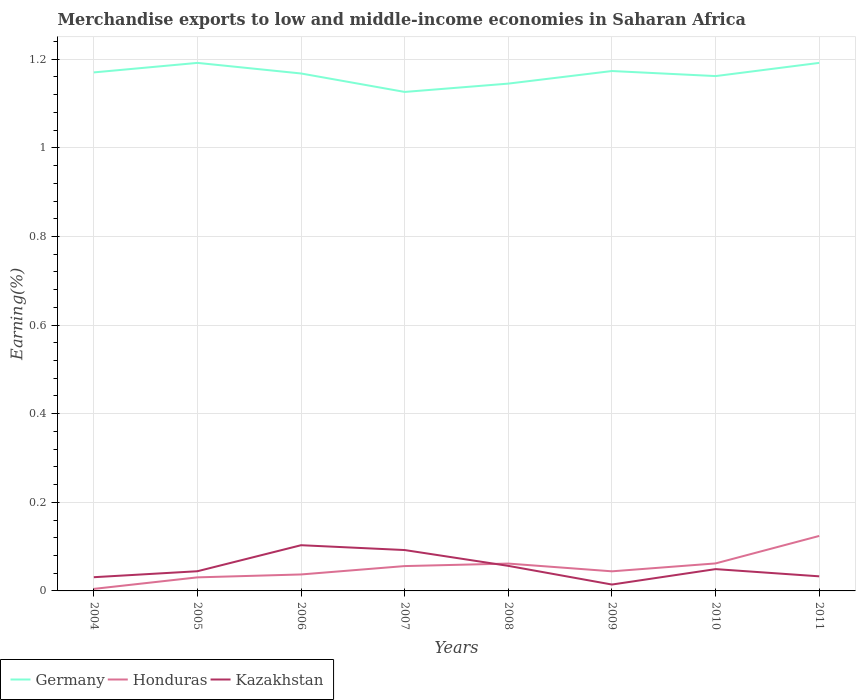How many different coloured lines are there?
Your answer should be compact. 3. Does the line corresponding to Honduras intersect with the line corresponding to Germany?
Offer a terse response. No. Is the number of lines equal to the number of legend labels?
Give a very brief answer. Yes. Across all years, what is the maximum percentage of amount earned from merchandise exports in Kazakhstan?
Your response must be concise. 0.01. What is the total percentage of amount earned from merchandise exports in Honduras in the graph?
Offer a very short reply. -0.02. What is the difference between the highest and the second highest percentage of amount earned from merchandise exports in Germany?
Keep it short and to the point. 0.07. What is the difference between the highest and the lowest percentage of amount earned from merchandise exports in Honduras?
Provide a short and direct response. 4. How many lines are there?
Make the answer very short. 3. What is the difference between two consecutive major ticks on the Y-axis?
Offer a very short reply. 0.2. Are the values on the major ticks of Y-axis written in scientific E-notation?
Your answer should be very brief. No. Does the graph contain any zero values?
Provide a succinct answer. No. Where does the legend appear in the graph?
Offer a terse response. Bottom left. How are the legend labels stacked?
Offer a terse response. Horizontal. What is the title of the graph?
Your response must be concise. Merchandise exports to low and middle-income economies in Saharan Africa. Does "Rwanda" appear as one of the legend labels in the graph?
Offer a very short reply. No. What is the label or title of the X-axis?
Keep it short and to the point. Years. What is the label or title of the Y-axis?
Make the answer very short. Earning(%). What is the Earning(%) of Germany in 2004?
Give a very brief answer. 1.17. What is the Earning(%) of Honduras in 2004?
Offer a terse response. 0. What is the Earning(%) of Kazakhstan in 2004?
Give a very brief answer. 0.03. What is the Earning(%) of Germany in 2005?
Give a very brief answer. 1.19. What is the Earning(%) in Honduras in 2005?
Keep it short and to the point. 0.03. What is the Earning(%) in Kazakhstan in 2005?
Provide a succinct answer. 0.04. What is the Earning(%) in Germany in 2006?
Give a very brief answer. 1.17. What is the Earning(%) in Honduras in 2006?
Your response must be concise. 0.04. What is the Earning(%) of Kazakhstan in 2006?
Offer a very short reply. 0.1. What is the Earning(%) of Germany in 2007?
Provide a short and direct response. 1.13. What is the Earning(%) in Honduras in 2007?
Offer a very short reply. 0.06. What is the Earning(%) in Kazakhstan in 2007?
Ensure brevity in your answer.  0.09. What is the Earning(%) of Germany in 2008?
Keep it short and to the point. 1.14. What is the Earning(%) in Honduras in 2008?
Provide a short and direct response. 0.06. What is the Earning(%) in Kazakhstan in 2008?
Offer a very short reply. 0.06. What is the Earning(%) in Germany in 2009?
Give a very brief answer. 1.17. What is the Earning(%) of Honduras in 2009?
Make the answer very short. 0.04. What is the Earning(%) of Kazakhstan in 2009?
Offer a terse response. 0.01. What is the Earning(%) of Germany in 2010?
Your answer should be compact. 1.16. What is the Earning(%) of Honduras in 2010?
Make the answer very short. 0.06. What is the Earning(%) in Kazakhstan in 2010?
Provide a short and direct response. 0.05. What is the Earning(%) of Germany in 2011?
Keep it short and to the point. 1.19. What is the Earning(%) in Honduras in 2011?
Give a very brief answer. 0.12. What is the Earning(%) of Kazakhstan in 2011?
Provide a short and direct response. 0.03. Across all years, what is the maximum Earning(%) in Germany?
Ensure brevity in your answer.  1.19. Across all years, what is the maximum Earning(%) in Honduras?
Keep it short and to the point. 0.12. Across all years, what is the maximum Earning(%) of Kazakhstan?
Offer a very short reply. 0.1. Across all years, what is the minimum Earning(%) of Germany?
Offer a very short reply. 1.13. Across all years, what is the minimum Earning(%) of Honduras?
Offer a terse response. 0. Across all years, what is the minimum Earning(%) in Kazakhstan?
Your answer should be very brief. 0.01. What is the total Earning(%) in Germany in the graph?
Keep it short and to the point. 9.33. What is the total Earning(%) of Honduras in the graph?
Keep it short and to the point. 0.42. What is the total Earning(%) of Kazakhstan in the graph?
Your response must be concise. 0.42. What is the difference between the Earning(%) in Germany in 2004 and that in 2005?
Ensure brevity in your answer.  -0.02. What is the difference between the Earning(%) of Honduras in 2004 and that in 2005?
Your response must be concise. -0.03. What is the difference between the Earning(%) in Kazakhstan in 2004 and that in 2005?
Offer a terse response. -0.01. What is the difference between the Earning(%) of Germany in 2004 and that in 2006?
Make the answer very short. 0. What is the difference between the Earning(%) of Honduras in 2004 and that in 2006?
Give a very brief answer. -0.03. What is the difference between the Earning(%) of Kazakhstan in 2004 and that in 2006?
Your answer should be compact. -0.07. What is the difference between the Earning(%) in Germany in 2004 and that in 2007?
Give a very brief answer. 0.04. What is the difference between the Earning(%) in Honduras in 2004 and that in 2007?
Your response must be concise. -0.05. What is the difference between the Earning(%) in Kazakhstan in 2004 and that in 2007?
Your answer should be very brief. -0.06. What is the difference between the Earning(%) in Germany in 2004 and that in 2008?
Offer a very short reply. 0.03. What is the difference between the Earning(%) in Honduras in 2004 and that in 2008?
Provide a short and direct response. -0.06. What is the difference between the Earning(%) in Kazakhstan in 2004 and that in 2008?
Offer a very short reply. -0.03. What is the difference between the Earning(%) of Germany in 2004 and that in 2009?
Your answer should be very brief. -0. What is the difference between the Earning(%) of Honduras in 2004 and that in 2009?
Your answer should be very brief. -0.04. What is the difference between the Earning(%) in Kazakhstan in 2004 and that in 2009?
Keep it short and to the point. 0.02. What is the difference between the Earning(%) in Germany in 2004 and that in 2010?
Your answer should be very brief. 0.01. What is the difference between the Earning(%) in Honduras in 2004 and that in 2010?
Keep it short and to the point. -0.06. What is the difference between the Earning(%) in Kazakhstan in 2004 and that in 2010?
Offer a very short reply. -0.02. What is the difference between the Earning(%) of Germany in 2004 and that in 2011?
Provide a succinct answer. -0.02. What is the difference between the Earning(%) in Honduras in 2004 and that in 2011?
Provide a short and direct response. -0.12. What is the difference between the Earning(%) of Kazakhstan in 2004 and that in 2011?
Your answer should be very brief. -0. What is the difference between the Earning(%) in Germany in 2005 and that in 2006?
Offer a very short reply. 0.02. What is the difference between the Earning(%) in Honduras in 2005 and that in 2006?
Your response must be concise. -0.01. What is the difference between the Earning(%) of Kazakhstan in 2005 and that in 2006?
Your response must be concise. -0.06. What is the difference between the Earning(%) in Germany in 2005 and that in 2007?
Offer a very short reply. 0.07. What is the difference between the Earning(%) in Honduras in 2005 and that in 2007?
Provide a succinct answer. -0.03. What is the difference between the Earning(%) in Kazakhstan in 2005 and that in 2007?
Provide a succinct answer. -0.05. What is the difference between the Earning(%) in Germany in 2005 and that in 2008?
Your answer should be compact. 0.05. What is the difference between the Earning(%) in Honduras in 2005 and that in 2008?
Give a very brief answer. -0.03. What is the difference between the Earning(%) in Kazakhstan in 2005 and that in 2008?
Offer a very short reply. -0.01. What is the difference between the Earning(%) in Germany in 2005 and that in 2009?
Your answer should be very brief. 0.02. What is the difference between the Earning(%) in Honduras in 2005 and that in 2009?
Offer a terse response. -0.01. What is the difference between the Earning(%) in Germany in 2005 and that in 2010?
Your answer should be very brief. 0.03. What is the difference between the Earning(%) in Honduras in 2005 and that in 2010?
Make the answer very short. -0.03. What is the difference between the Earning(%) in Kazakhstan in 2005 and that in 2010?
Offer a very short reply. -0. What is the difference between the Earning(%) in Germany in 2005 and that in 2011?
Provide a succinct answer. -0. What is the difference between the Earning(%) in Honduras in 2005 and that in 2011?
Offer a very short reply. -0.09. What is the difference between the Earning(%) of Kazakhstan in 2005 and that in 2011?
Your response must be concise. 0.01. What is the difference between the Earning(%) of Germany in 2006 and that in 2007?
Your answer should be very brief. 0.04. What is the difference between the Earning(%) of Honduras in 2006 and that in 2007?
Offer a very short reply. -0.02. What is the difference between the Earning(%) in Kazakhstan in 2006 and that in 2007?
Offer a terse response. 0.01. What is the difference between the Earning(%) in Germany in 2006 and that in 2008?
Provide a short and direct response. 0.02. What is the difference between the Earning(%) in Honduras in 2006 and that in 2008?
Make the answer very short. -0.02. What is the difference between the Earning(%) of Kazakhstan in 2006 and that in 2008?
Ensure brevity in your answer.  0.05. What is the difference between the Earning(%) of Germany in 2006 and that in 2009?
Offer a terse response. -0.01. What is the difference between the Earning(%) of Honduras in 2006 and that in 2009?
Provide a short and direct response. -0.01. What is the difference between the Earning(%) of Kazakhstan in 2006 and that in 2009?
Offer a terse response. 0.09. What is the difference between the Earning(%) of Germany in 2006 and that in 2010?
Offer a terse response. 0.01. What is the difference between the Earning(%) in Honduras in 2006 and that in 2010?
Provide a short and direct response. -0.02. What is the difference between the Earning(%) in Kazakhstan in 2006 and that in 2010?
Offer a terse response. 0.05. What is the difference between the Earning(%) of Germany in 2006 and that in 2011?
Your answer should be compact. -0.02. What is the difference between the Earning(%) of Honduras in 2006 and that in 2011?
Provide a succinct answer. -0.09. What is the difference between the Earning(%) of Kazakhstan in 2006 and that in 2011?
Make the answer very short. 0.07. What is the difference between the Earning(%) in Germany in 2007 and that in 2008?
Offer a terse response. -0.02. What is the difference between the Earning(%) in Honduras in 2007 and that in 2008?
Make the answer very short. -0.01. What is the difference between the Earning(%) in Kazakhstan in 2007 and that in 2008?
Provide a short and direct response. 0.04. What is the difference between the Earning(%) of Germany in 2007 and that in 2009?
Your response must be concise. -0.05. What is the difference between the Earning(%) of Honduras in 2007 and that in 2009?
Provide a succinct answer. 0.01. What is the difference between the Earning(%) of Kazakhstan in 2007 and that in 2009?
Your answer should be compact. 0.08. What is the difference between the Earning(%) in Germany in 2007 and that in 2010?
Provide a succinct answer. -0.04. What is the difference between the Earning(%) in Honduras in 2007 and that in 2010?
Your response must be concise. -0.01. What is the difference between the Earning(%) in Kazakhstan in 2007 and that in 2010?
Make the answer very short. 0.04. What is the difference between the Earning(%) in Germany in 2007 and that in 2011?
Ensure brevity in your answer.  -0.07. What is the difference between the Earning(%) of Honduras in 2007 and that in 2011?
Provide a succinct answer. -0.07. What is the difference between the Earning(%) of Kazakhstan in 2007 and that in 2011?
Provide a succinct answer. 0.06. What is the difference between the Earning(%) of Germany in 2008 and that in 2009?
Give a very brief answer. -0.03. What is the difference between the Earning(%) in Honduras in 2008 and that in 2009?
Provide a succinct answer. 0.02. What is the difference between the Earning(%) in Kazakhstan in 2008 and that in 2009?
Make the answer very short. 0.04. What is the difference between the Earning(%) of Germany in 2008 and that in 2010?
Your answer should be compact. -0.02. What is the difference between the Earning(%) of Honduras in 2008 and that in 2010?
Your answer should be compact. -0. What is the difference between the Earning(%) of Kazakhstan in 2008 and that in 2010?
Provide a succinct answer. 0.01. What is the difference between the Earning(%) in Germany in 2008 and that in 2011?
Give a very brief answer. -0.05. What is the difference between the Earning(%) of Honduras in 2008 and that in 2011?
Your answer should be compact. -0.06. What is the difference between the Earning(%) in Kazakhstan in 2008 and that in 2011?
Provide a succinct answer. 0.02. What is the difference between the Earning(%) in Germany in 2009 and that in 2010?
Offer a very short reply. 0.01. What is the difference between the Earning(%) in Honduras in 2009 and that in 2010?
Offer a terse response. -0.02. What is the difference between the Earning(%) in Kazakhstan in 2009 and that in 2010?
Give a very brief answer. -0.03. What is the difference between the Earning(%) of Germany in 2009 and that in 2011?
Ensure brevity in your answer.  -0.02. What is the difference between the Earning(%) of Honduras in 2009 and that in 2011?
Your response must be concise. -0.08. What is the difference between the Earning(%) of Kazakhstan in 2009 and that in 2011?
Your answer should be compact. -0.02. What is the difference between the Earning(%) of Germany in 2010 and that in 2011?
Provide a succinct answer. -0.03. What is the difference between the Earning(%) of Honduras in 2010 and that in 2011?
Provide a short and direct response. -0.06. What is the difference between the Earning(%) in Kazakhstan in 2010 and that in 2011?
Your response must be concise. 0.02. What is the difference between the Earning(%) in Germany in 2004 and the Earning(%) in Honduras in 2005?
Keep it short and to the point. 1.14. What is the difference between the Earning(%) of Germany in 2004 and the Earning(%) of Kazakhstan in 2005?
Your answer should be very brief. 1.13. What is the difference between the Earning(%) of Honduras in 2004 and the Earning(%) of Kazakhstan in 2005?
Make the answer very short. -0.04. What is the difference between the Earning(%) in Germany in 2004 and the Earning(%) in Honduras in 2006?
Make the answer very short. 1.13. What is the difference between the Earning(%) in Germany in 2004 and the Earning(%) in Kazakhstan in 2006?
Ensure brevity in your answer.  1.07. What is the difference between the Earning(%) in Honduras in 2004 and the Earning(%) in Kazakhstan in 2006?
Offer a very short reply. -0.1. What is the difference between the Earning(%) in Germany in 2004 and the Earning(%) in Honduras in 2007?
Give a very brief answer. 1.11. What is the difference between the Earning(%) in Germany in 2004 and the Earning(%) in Kazakhstan in 2007?
Give a very brief answer. 1.08. What is the difference between the Earning(%) of Honduras in 2004 and the Earning(%) of Kazakhstan in 2007?
Provide a short and direct response. -0.09. What is the difference between the Earning(%) in Germany in 2004 and the Earning(%) in Honduras in 2008?
Make the answer very short. 1.11. What is the difference between the Earning(%) of Germany in 2004 and the Earning(%) of Kazakhstan in 2008?
Keep it short and to the point. 1.11. What is the difference between the Earning(%) of Honduras in 2004 and the Earning(%) of Kazakhstan in 2008?
Make the answer very short. -0.05. What is the difference between the Earning(%) of Germany in 2004 and the Earning(%) of Honduras in 2009?
Give a very brief answer. 1.13. What is the difference between the Earning(%) of Germany in 2004 and the Earning(%) of Kazakhstan in 2009?
Give a very brief answer. 1.16. What is the difference between the Earning(%) of Honduras in 2004 and the Earning(%) of Kazakhstan in 2009?
Offer a very short reply. -0.01. What is the difference between the Earning(%) of Germany in 2004 and the Earning(%) of Honduras in 2010?
Make the answer very short. 1.11. What is the difference between the Earning(%) in Germany in 2004 and the Earning(%) in Kazakhstan in 2010?
Your response must be concise. 1.12. What is the difference between the Earning(%) in Honduras in 2004 and the Earning(%) in Kazakhstan in 2010?
Offer a terse response. -0.04. What is the difference between the Earning(%) of Germany in 2004 and the Earning(%) of Honduras in 2011?
Ensure brevity in your answer.  1.05. What is the difference between the Earning(%) of Germany in 2004 and the Earning(%) of Kazakhstan in 2011?
Offer a terse response. 1.14. What is the difference between the Earning(%) of Honduras in 2004 and the Earning(%) of Kazakhstan in 2011?
Make the answer very short. -0.03. What is the difference between the Earning(%) in Germany in 2005 and the Earning(%) in Honduras in 2006?
Provide a short and direct response. 1.15. What is the difference between the Earning(%) of Germany in 2005 and the Earning(%) of Kazakhstan in 2006?
Ensure brevity in your answer.  1.09. What is the difference between the Earning(%) in Honduras in 2005 and the Earning(%) in Kazakhstan in 2006?
Your answer should be very brief. -0.07. What is the difference between the Earning(%) of Germany in 2005 and the Earning(%) of Honduras in 2007?
Offer a very short reply. 1.14. What is the difference between the Earning(%) in Germany in 2005 and the Earning(%) in Kazakhstan in 2007?
Your answer should be very brief. 1.1. What is the difference between the Earning(%) of Honduras in 2005 and the Earning(%) of Kazakhstan in 2007?
Give a very brief answer. -0.06. What is the difference between the Earning(%) of Germany in 2005 and the Earning(%) of Honduras in 2008?
Offer a terse response. 1.13. What is the difference between the Earning(%) of Germany in 2005 and the Earning(%) of Kazakhstan in 2008?
Ensure brevity in your answer.  1.14. What is the difference between the Earning(%) of Honduras in 2005 and the Earning(%) of Kazakhstan in 2008?
Make the answer very short. -0.03. What is the difference between the Earning(%) of Germany in 2005 and the Earning(%) of Honduras in 2009?
Your answer should be compact. 1.15. What is the difference between the Earning(%) of Germany in 2005 and the Earning(%) of Kazakhstan in 2009?
Your answer should be compact. 1.18. What is the difference between the Earning(%) of Honduras in 2005 and the Earning(%) of Kazakhstan in 2009?
Your answer should be compact. 0.02. What is the difference between the Earning(%) of Germany in 2005 and the Earning(%) of Honduras in 2010?
Provide a short and direct response. 1.13. What is the difference between the Earning(%) in Germany in 2005 and the Earning(%) in Kazakhstan in 2010?
Provide a short and direct response. 1.14. What is the difference between the Earning(%) in Honduras in 2005 and the Earning(%) in Kazakhstan in 2010?
Your answer should be very brief. -0.02. What is the difference between the Earning(%) in Germany in 2005 and the Earning(%) in Honduras in 2011?
Ensure brevity in your answer.  1.07. What is the difference between the Earning(%) in Germany in 2005 and the Earning(%) in Kazakhstan in 2011?
Your answer should be compact. 1.16. What is the difference between the Earning(%) of Honduras in 2005 and the Earning(%) of Kazakhstan in 2011?
Your answer should be compact. -0. What is the difference between the Earning(%) of Germany in 2006 and the Earning(%) of Honduras in 2007?
Provide a succinct answer. 1.11. What is the difference between the Earning(%) of Germany in 2006 and the Earning(%) of Kazakhstan in 2007?
Provide a short and direct response. 1.08. What is the difference between the Earning(%) of Honduras in 2006 and the Earning(%) of Kazakhstan in 2007?
Offer a terse response. -0.06. What is the difference between the Earning(%) of Germany in 2006 and the Earning(%) of Honduras in 2008?
Provide a short and direct response. 1.11. What is the difference between the Earning(%) of Germany in 2006 and the Earning(%) of Kazakhstan in 2008?
Keep it short and to the point. 1.11. What is the difference between the Earning(%) of Honduras in 2006 and the Earning(%) of Kazakhstan in 2008?
Give a very brief answer. -0.02. What is the difference between the Earning(%) of Germany in 2006 and the Earning(%) of Honduras in 2009?
Your answer should be very brief. 1.12. What is the difference between the Earning(%) in Germany in 2006 and the Earning(%) in Kazakhstan in 2009?
Provide a succinct answer. 1.15. What is the difference between the Earning(%) of Honduras in 2006 and the Earning(%) of Kazakhstan in 2009?
Your answer should be compact. 0.02. What is the difference between the Earning(%) in Germany in 2006 and the Earning(%) in Honduras in 2010?
Offer a terse response. 1.11. What is the difference between the Earning(%) in Germany in 2006 and the Earning(%) in Kazakhstan in 2010?
Keep it short and to the point. 1.12. What is the difference between the Earning(%) of Honduras in 2006 and the Earning(%) of Kazakhstan in 2010?
Provide a short and direct response. -0.01. What is the difference between the Earning(%) in Germany in 2006 and the Earning(%) in Honduras in 2011?
Offer a terse response. 1.04. What is the difference between the Earning(%) in Germany in 2006 and the Earning(%) in Kazakhstan in 2011?
Make the answer very short. 1.13. What is the difference between the Earning(%) of Honduras in 2006 and the Earning(%) of Kazakhstan in 2011?
Provide a succinct answer. 0. What is the difference between the Earning(%) of Germany in 2007 and the Earning(%) of Honduras in 2008?
Your answer should be compact. 1.06. What is the difference between the Earning(%) of Germany in 2007 and the Earning(%) of Kazakhstan in 2008?
Make the answer very short. 1.07. What is the difference between the Earning(%) in Honduras in 2007 and the Earning(%) in Kazakhstan in 2008?
Offer a terse response. -0. What is the difference between the Earning(%) in Germany in 2007 and the Earning(%) in Honduras in 2009?
Your answer should be very brief. 1.08. What is the difference between the Earning(%) of Germany in 2007 and the Earning(%) of Kazakhstan in 2009?
Your answer should be compact. 1.11. What is the difference between the Earning(%) of Honduras in 2007 and the Earning(%) of Kazakhstan in 2009?
Your answer should be compact. 0.04. What is the difference between the Earning(%) in Germany in 2007 and the Earning(%) in Honduras in 2010?
Make the answer very short. 1.06. What is the difference between the Earning(%) of Germany in 2007 and the Earning(%) of Kazakhstan in 2010?
Your answer should be compact. 1.08. What is the difference between the Earning(%) in Honduras in 2007 and the Earning(%) in Kazakhstan in 2010?
Offer a terse response. 0.01. What is the difference between the Earning(%) of Germany in 2007 and the Earning(%) of Kazakhstan in 2011?
Offer a terse response. 1.09. What is the difference between the Earning(%) of Honduras in 2007 and the Earning(%) of Kazakhstan in 2011?
Offer a very short reply. 0.02. What is the difference between the Earning(%) in Germany in 2008 and the Earning(%) in Honduras in 2009?
Your response must be concise. 1.1. What is the difference between the Earning(%) of Germany in 2008 and the Earning(%) of Kazakhstan in 2009?
Provide a succinct answer. 1.13. What is the difference between the Earning(%) of Honduras in 2008 and the Earning(%) of Kazakhstan in 2009?
Keep it short and to the point. 0.05. What is the difference between the Earning(%) in Germany in 2008 and the Earning(%) in Honduras in 2010?
Your answer should be very brief. 1.08. What is the difference between the Earning(%) in Germany in 2008 and the Earning(%) in Kazakhstan in 2010?
Your answer should be very brief. 1.1. What is the difference between the Earning(%) of Honduras in 2008 and the Earning(%) of Kazakhstan in 2010?
Your answer should be compact. 0.01. What is the difference between the Earning(%) of Germany in 2008 and the Earning(%) of Honduras in 2011?
Keep it short and to the point. 1.02. What is the difference between the Earning(%) of Germany in 2008 and the Earning(%) of Kazakhstan in 2011?
Your answer should be very brief. 1.11. What is the difference between the Earning(%) of Honduras in 2008 and the Earning(%) of Kazakhstan in 2011?
Offer a terse response. 0.03. What is the difference between the Earning(%) in Germany in 2009 and the Earning(%) in Honduras in 2010?
Your answer should be very brief. 1.11. What is the difference between the Earning(%) of Germany in 2009 and the Earning(%) of Kazakhstan in 2010?
Provide a short and direct response. 1.12. What is the difference between the Earning(%) in Honduras in 2009 and the Earning(%) in Kazakhstan in 2010?
Give a very brief answer. -0.01. What is the difference between the Earning(%) in Germany in 2009 and the Earning(%) in Honduras in 2011?
Give a very brief answer. 1.05. What is the difference between the Earning(%) in Germany in 2009 and the Earning(%) in Kazakhstan in 2011?
Keep it short and to the point. 1.14. What is the difference between the Earning(%) in Honduras in 2009 and the Earning(%) in Kazakhstan in 2011?
Your response must be concise. 0.01. What is the difference between the Earning(%) of Germany in 2010 and the Earning(%) of Honduras in 2011?
Keep it short and to the point. 1.04. What is the difference between the Earning(%) in Germany in 2010 and the Earning(%) in Kazakhstan in 2011?
Your answer should be very brief. 1.13. What is the difference between the Earning(%) in Honduras in 2010 and the Earning(%) in Kazakhstan in 2011?
Keep it short and to the point. 0.03. What is the average Earning(%) in Germany per year?
Provide a succinct answer. 1.17. What is the average Earning(%) of Honduras per year?
Your answer should be compact. 0.05. What is the average Earning(%) in Kazakhstan per year?
Offer a terse response. 0.05. In the year 2004, what is the difference between the Earning(%) of Germany and Earning(%) of Honduras?
Give a very brief answer. 1.17. In the year 2004, what is the difference between the Earning(%) in Germany and Earning(%) in Kazakhstan?
Your response must be concise. 1.14. In the year 2004, what is the difference between the Earning(%) of Honduras and Earning(%) of Kazakhstan?
Ensure brevity in your answer.  -0.03. In the year 2005, what is the difference between the Earning(%) in Germany and Earning(%) in Honduras?
Your response must be concise. 1.16. In the year 2005, what is the difference between the Earning(%) in Germany and Earning(%) in Kazakhstan?
Your answer should be compact. 1.15. In the year 2005, what is the difference between the Earning(%) of Honduras and Earning(%) of Kazakhstan?
Give a very brief answer. -0.01. In the year 2006, what is the difference between the Earning(%) in Germany and Earning(%) in Honduras?
Keep it short and to the point. 1.13. In the year 2006, what is the difference between the Earning(%) of Germany and Earning(%) of Kazakhstan?
Offer a very short reply. 1.06. In the year 2006, what is the difference between the Earning(%) of Honduras and Earning(%) of Kazakhstan?
Provide a short and direct response. -0.07. In the year 2007, what is the difference between the Earning(%) in Germany and Earning(%) in Honduras?
Ensure brevity in your answer.  1.07. In the year 2007, what is the difference between the Earning(%) in Germany and Earning(%) in Kazakhstan?
Provide a succinct answer. 1.03. In the year 2007, what is the difference between the Earning(%) of Honduras and Earning(%) of Kazakhstan?
Make the answer very short. -0.04. In the year 2008, what is the difference between the Earning(%) in Germany and Earning(%) in Kazakhstan?
Provide a succinct answer. 1.09. In the year 2008, what is the difference between the Earning(%) of Honduras and Earning(%) of Kazakhstan?
Offer a terse response. 0.01. In the year 2009, what is the difference between the Earning(%) in Germany and Earning(%) in Honduras?
Your answer should be compact. 1.13. In the year 2009, what is the difference between the Earning(%) of Germany and Earning(%) of Kazakhstan?
Your answer should be compact. 1.16. In the year 2009, what is the difference between the Earning(%) of Honduras and Earning(%) of Kazakhstan?
Make the answer very short. 0.03. In the year 2010, what is the difference between the Earning(%) in Germany and Earning(%) in Honduras?
Ensure brevity in your answer.  1.1. In the year 2010, what is the difference between the Earning(%) in Germany and Earning(%) in Kazakhstan?
Your answer should be very brief. 1.11. In the year 2010, what is the difference between the Earning(%) in Honduras and Earning(%) in Kazakhstan?
Offer a terse response. 0.01. In the year 2011, what is the difference between the Earning(%) in Germany and Earning(%) in Honduras?
Provide a short and direct response. 1.07. In the year 2011, what is the difference between the Earning(%) of Germany and Earning(%) of Kazakhstan?
Your answer should be very brief. 1.16. In the year 2011, what is the difference between the Earning(%) in Honduras and Earning(%) in Kazakhstan?
Keep it short and to the point. 0.09. What is the ratio of the Earning(%) of Honduras in 2004 to that in 2005?
Give a very brief answer. 0.15. What is the ratio of the Earning(%) of Kazakhstan in 2004 to that in 2005?
Provide a short and direct response. 0.7. What is the ratio of the Earning(%) of Germany in 2004 to that in 2006?
Make the answer very short. 1. What is the ratio of the Earning(%) in Honduras in 2004 to that in 2006?
Ensure brevity in your answer.  0.12. What is the ratio of the Earning(%) of Kazakhstan in 2004 to that in 2006?
Provide a short and direct response. 0.3. What is the ratio of the Earning(%) in Germany in 2004 to that in 2007?
Ensure brevity in your answer.  1.04. What is the ratio of the Earning(%) of Honduras in 2004 to that in 2007?
Offer a very short reply. 0.08. What is the ratio of the Earning(%) in Kazakhstan in 2004 to that in 2007?
Your answer should be very brief. 0.34. What is the ratio of the Earning(%) in Germany in 2004 to that in 2008?
Keep it short and to the point. 1.02. What is the ratio of the Earning(%) of Honduras in 2004 to that in 2008?
Provide a succinct answer. 0.07. What is the ratio of the Earning(%) in Kazakhstan in 2004 to that in 2008?
Ensure brevity in your answer.  0.55. What is the ratio of the Earning(%) of Germany in 2004 to that in 2009?
Make the answer very short. 1. What is the ratio of the Earning(%) in Honduras in 2004 to that in 2009?
Offer a terse response. 0.1. What is the ratio of the Earning(%) in Kazakhstan in 2004 to that in 2009?
Make the answer very short. 2.15. What is the ratio of the Earning(%) in Germany in 2004 to that in 2010?
Your answer should be very brief. 1.01. What is the ratio of the Earning(%) in Honduras in 2004 to that in 2010?
Provide a succinct answer. 0.07. What is the ratio of the Earning(%) of Kazakhstan in 2004 to that in 2010?
Your response must be concise. 0.63. What is the ratio of the Earning(%) in Germany in 2004 to that in 2011?
Your answer should be compact. 0.98. What is the ratio of the Earning(%) of Honduras in 2004 to that in 2011?
Provide a succinct answer. 0.04. What is the ratio of the Earning(%) in Kazakhstan in 2004 to that in 2011?
Keep it short and to the point. 0.94. What is the ratio of the Earning(%) of Germany in 2005 to that in 2006?
Give a very brief answer. 1.02. What is the ratio of the Earning(%) in Honduras in 2005 to that in 2006?
Keep it short and to the point. 0.82. What is the ratio of the Earning(%) in Kazakhstan in 2005 to that in 2006?
Provide a short and direct response. 0.43. What is the ratio of the Earning(%) in Germany in 2005 to that in 2007?
Ensure brevity in your answer.  1.06. What is the ratio of the Earning(%) in Honduras in 2005 to that in 2007?
Your response must be concise. 0.55. What is the ratio of the Earning(%) of Kazakhstan in 2005 to that in 2007?
Offer a terse response. 0.48. What is the ratio of the Earning(%) of Germany in 2005 to that in 2008?
Keep it short and to the point. 1.04. What is the ratio of the Earning(%) of Honduras in 2005 to that in 2008?
Keep it short and to the point. 0.5. What is the ratio of the Earning(%) in Kazakhstan in 2005 to that in 2008?
Make the answer very short. 0.79. What is the ratio of the Earning(%) in Germany in 2005 to that in 2009?
Keep it short and to the point. 1.02. What is the ratio of the Earning(%) of Honduras in 2005 to that in 2009?
Provide a short and direct response. 0.69. What is the ratio of the Earning(%) of Kazakhstan in 2005 to that in 2009?
Your answer should be compact. 3.09. What is the ratio of the Earning(%) of Germany in 2005 to that in 2010?
Make the answer very short. 1.03. What is the ratio of the Earning(%) in Honduras in 2005 to that in 2010?
Provide a short and direct response. 0.49. What is the ratio of the Earning(%) of Kazakhstan in 2005 to that in 2010?
Keep it short and to the point. 0.9. What is the ratio of the Earning(%) in Germany in 2005 to that in 2011?
Provide a succinct answer. 1. What is the ratio of the Earning(%) in Honduras in 2005 to that in 2011?
Offer a terse response. 0.25. What is the ratio of the Earning(%) in Kazakhstan in 2005 to that in 2011?
Ensure brevity in your answer.  1.35. What is the ratio of the Earning(%) in Honduras in 2006 to that in 2007?
Your answer should be very brief. 0.66. What is the ratio of the Earning(%) of Kazakhstan in 2006 to that in 2007?
Provide a succinct answer. 1.12. What is the ratio of the Earning(%) in Germany in 2006 to that in 2008?
Ensure brevity in your answer.  1.02. What is the ratio of the Earning(%) of Honduras in 2006 to that in 2008?
Ensure brevity in your answer.  0.6. What is the ratio of the Earning(%) in Kazakhstan in 2006 to that in 2008?
Your answer should be compact. 1.82. What is the ratio of the Earning(%) in Honduras in 2006 to that in 2009?
Offer a terse response. 0.84. What is the ratio of the Earning(%) of Kazakhstan in 2006 to that in 2009?
Provide a succinct answer. 7.17. What is the ratio of the Earning(%) of Honduras in 2006 to that in 2010?
Your response must be concise. 0.6. What is the ratio of the Earning(%) in Kazakhstan in 2006 to that in 2010?
Provide a short and direct response. 2.1. What is the ratio of the Earning(%) of Germany in 2006 to that in 2011?
Your answer should be compact. 0.98. What is the ratio of the Earning(%) of Honduras in 2006 to that in 2011?
Ensure brevity in your answer.  0.3. What is the ratio of the Earning(%) of Kazakhstan in 2006 to that in 2011?
Your response must be concise. 3.13. What is the ratio of the Earning(%) in Germany in 2007 to that in 2008?
Ensure brevity in your answer.  0.98. What is the ratio of the Earning(%) in Honduras in 2007 to that in 2008?
Offer a terse response. 0.91. What is the ratio of the Earning(%) in Kazakhstan in 2007 to that in 2008?
Keep it short and to the point. 1.63. What is the ratio of the Earning(%) in Germany in 2007 to that in 2009?
Offer a terse response. 0.96. What is the ratio of the Earning(%) of Honduras in 2007 to that in 2009?
Offer a very short reply. 1.27. What is the ratio of the Earning(%) of Kazakhstan in 2007 to that in 2009?
Your answer should be compact. 6.41. What is the ratio of the Earning(%) of Germany in 2007 to that in 2010?
Keep it short and to the point. 0.97. What is the ratio of the Earning(%) in Honduras in 2007 to that in 2010?
Your answer should be compact. 0.9. What is the ratio of the Earning(%) in Kazakhstan in 2007 to that in 2010?
Ensure brevity in your answer.  1.87. What is the ratio of the Earning(%) in Germany in 2007 to that in 2011?
Keep it short and to the point. 0.94. What is the ratio of the Earning(%) of Honduras in 2007 to that in 2011?
Offer a very short reply. 0.45. What is the ratio of the Earning(%) of Kazakhstan in 2007 to that in 2011?
Offer a terse response. 2.8. What is the ratio of the Earning(%) of Germany in 2008 to that in 2009?
Offer a terse response. 0.98. What is the ratio of the Earning(%) in Honduras in 2008 to that in 2009?
Your answer should be compact. 1.4. What is the ratio of the Earning(%) of Kazakhstan in 2008 to that in 2009?
Give a very brief answer. 3.93. What is the ratio of the Earning(%) in Germany in 2008 to that in 2010?
Ensure brevity in your answer.  0.99. What is the ratio of the Earning(%) of Honduras in 2008 to that in 2010?
Give a very brief answer. 0.99. What is the ratio of the Earning(%) of Kazakhstan in 2008 to that in 2010?
Your answer should be very brief. 1.15. What is the ratio of the Earning(%) of Germany in 2008 to that in 2011?
Your answer should be compact. 0.96. What is the ratio of the Earning(%) of Honduras in 2008 to that in 2011?
Give a very brief answer. 0.5. What is the ratio of the Earning(%) in Kazakhstan in 2008 to that in 2011?
Your answer should be very brief. 1.72. What is the ratio of the Earning(%) in Germany in 2009 to that in 2010?
Provide a short and direct response. 1.01. What is the ratio of the Earning(%) in Honduras in 2009 to that in 2010?
Ensure brevity in your answer.  0.71. What is the ratio of the Earning(%) in Kazakhstan in 2009 to that in 2010?
Your answer should be very brief. 0.29. What is the ratio of the Earning(%) in Germany in 2009 to that in 2011?
Your answer should be very brief. 0.98. What is the ratio of the Earning(%) in Honduras in 2009 to that in 2011?
Ensure brevity in your answer.  0.36. What is the ratio of the Earning(%) of Kazakhstan in 2009 to that in 2011?
Provide a short and direct response. 0.44. What is the ratio of the Earning(%) in Germany in 2010 to that in 2011?
Provide a short and direct response. 0.97. What is the ratio of the Earning(%) in Honduras in 2010 to that in 2011?
Provide a short and direct response. 0.5. What is the ratio of the Earning(%) of Kazakhstan in 2010 to that in 2011?
Ensure brevity in your answer.  1.49. What is the difference between the highest and the second highest Earning(%) of Honduras?
Keep it short and to the point. 0.06. What is the difference between the highest and the second highest Earning(%) in Kazakhstan?
Provide a succinct answer. 0.01. What is the difference between the highest and the lowest Earning(%) in Germany?
Offer a very short reply. 0.07. What is the difference between the highest and the lowest Earning(%) of Honduras?
Provide a succinct answer. 0.12. What is the difference between the highest and the lowest Earning(%) of Kazakhstan?
Provide a succinct answer. 0.09. 